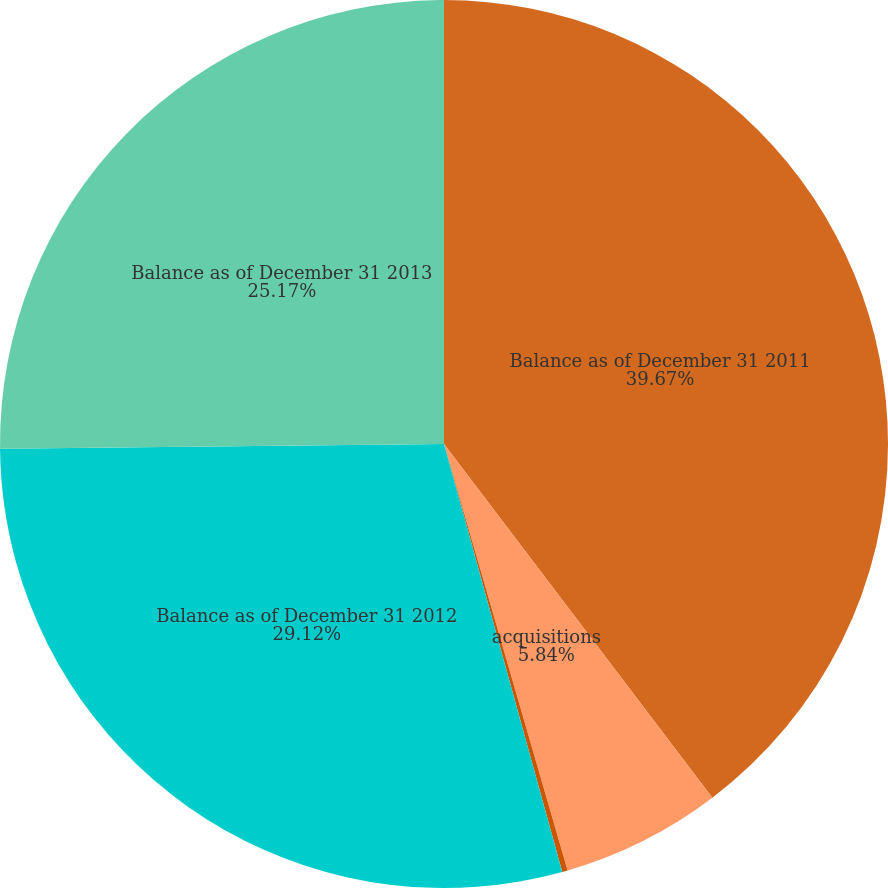Convert chart to OTSL. <chart><loc_0><loc_0><loc_500><loc_500><pie_chart><fcel>Balance as of December 31 2011<fcel>acquisitions<fcel>other (primarily fx)<fcel>Balance as of December 31 2012<fcel>Balance as of December 31 2013<nl><fcel>39.67%<fcel>5.84%<fcel>0.2%<fcel>29.12%<fcel>25.17%<nl></chart> 